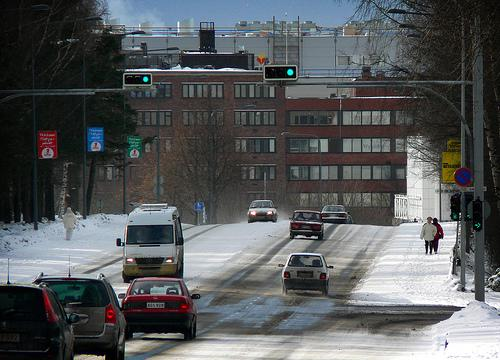Give an overview of the image indicating the type of weather and the activities happening. The image depicts snowy weather in a city, with cars driving carefully while having their headlights on and pedestrians walking in the snow. Summarize the scene captured in the image and the behavior of the subjects involved. The image displays a snowy city street with hazardous driving conditions, where cars drive cautiously, and pedestrians walk through the snow. What is the main theme of the image and what are people doing about it? The main theme is hazardous driving conditions due to snow, and people are driving carefully while pedestrians walk through the snow. Identify the main focus of the image and give a brief explanation of the scene. The primary focus is on snowy city streets with several vehicles driving slowly and cautiously, and pedestrians in the snow, due to hazardous driving conditions. Briefly describe the setting and the people in the image. The setting is a snowy city street with slippery roads, where people are driving cautiously, and pedestrians are walking in the snow. Identify the existing conditions and how are individuals responding to them in the image. The image features slippery, snowy streets, and individuals are driving cautiously with headlights on, while pedestrians walk in the snow. Mention the prominent features in the image along with the activities happening around them. Prominent features include snowy streets, multiple vehicles, and pedestrians. Activities include driving cautiously and walking in the snow. Provide a concise description of the overall image and the actions taking place within it. The image captures a snowy city street where vehicles drive cautiously with headlights on and pedestrians walk in the snow. Describe the general environment in the image along with the actions of the people there. The image shows a snowy city with slippery streets, where cautious driving is observed, cars have their headlights on, and pedestrians navigate through the snow. What is the weather like in the image and how are people dealing with it? The weather is snowy, causing hazardous driving conditions, and people are driving carefully while pedestrians walk through the snow. 